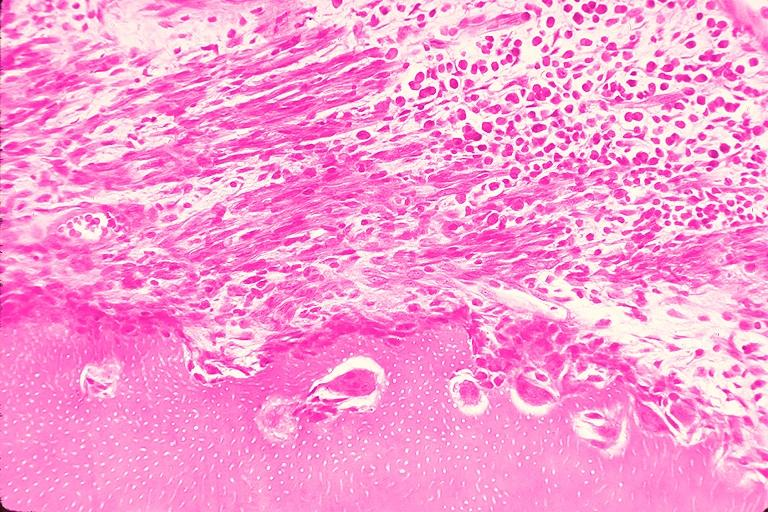does chronic myelogenous leukemia in blast crisis show resorption?
Answer the question using a single word or phrase. No 